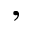Convert formula to latex. <formula><loc_0><loc_0><loc_500><loc_500>,</formula> 